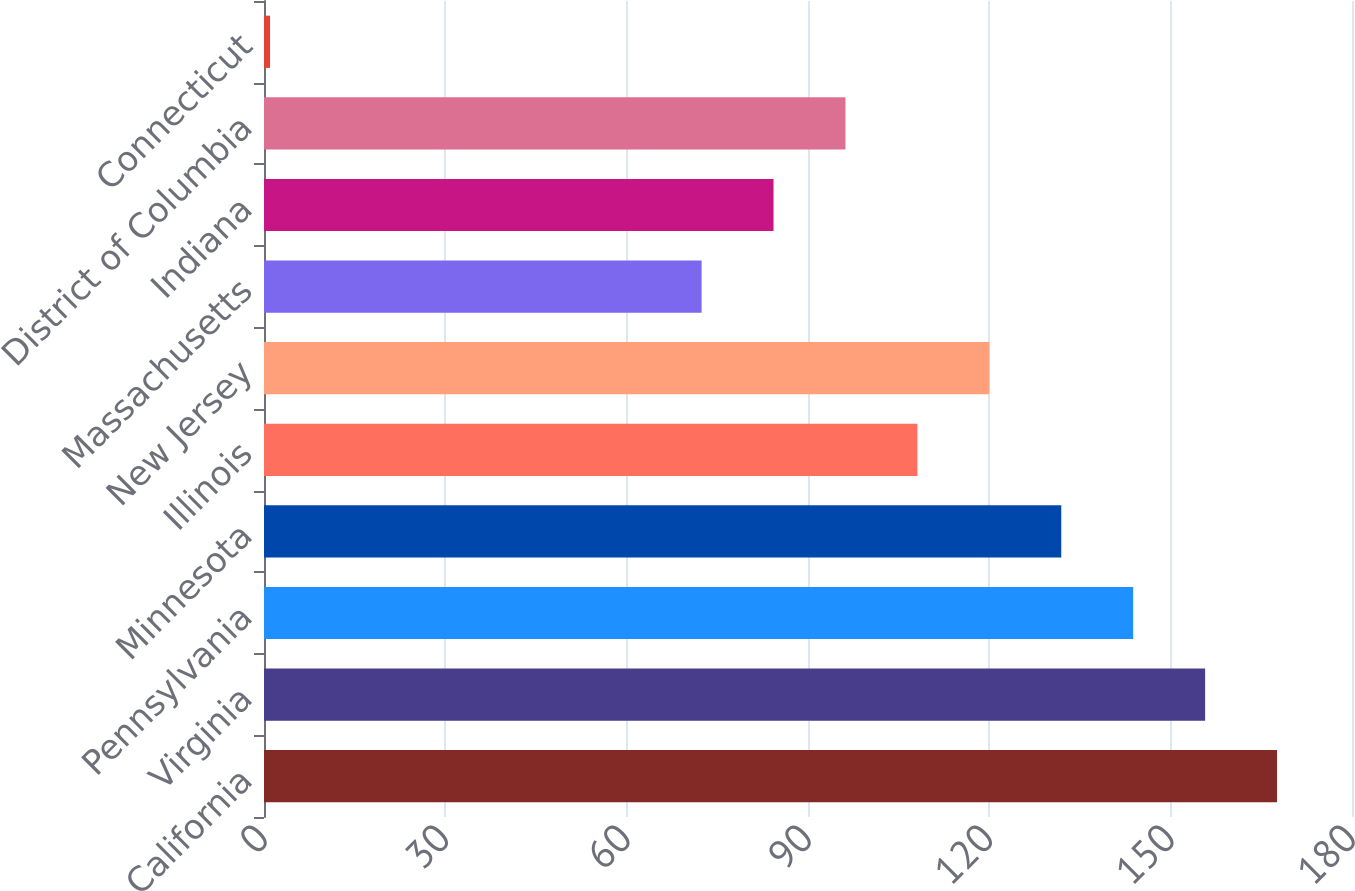Convert chart. <chart><loc_0><loc_0><loc_500><loc_500><bar_chart><fcel>California<fcel>Virginia<fcel>Pennsylvania<fcel>Minnesota<fcel>Illinois<fcel>New Jersey<fcel>Massachusetts<fcel>Indiana<fcel>District of Columbia<fcel>Connecticut<nl><fcel>167.6<fcel>155.7<fcel>143.8<fcel>131.9<fcel>108.1<fcel>120<fcel>72.4<fcel>84.3<fcel>96.2<fcel>1<nl></chart> 